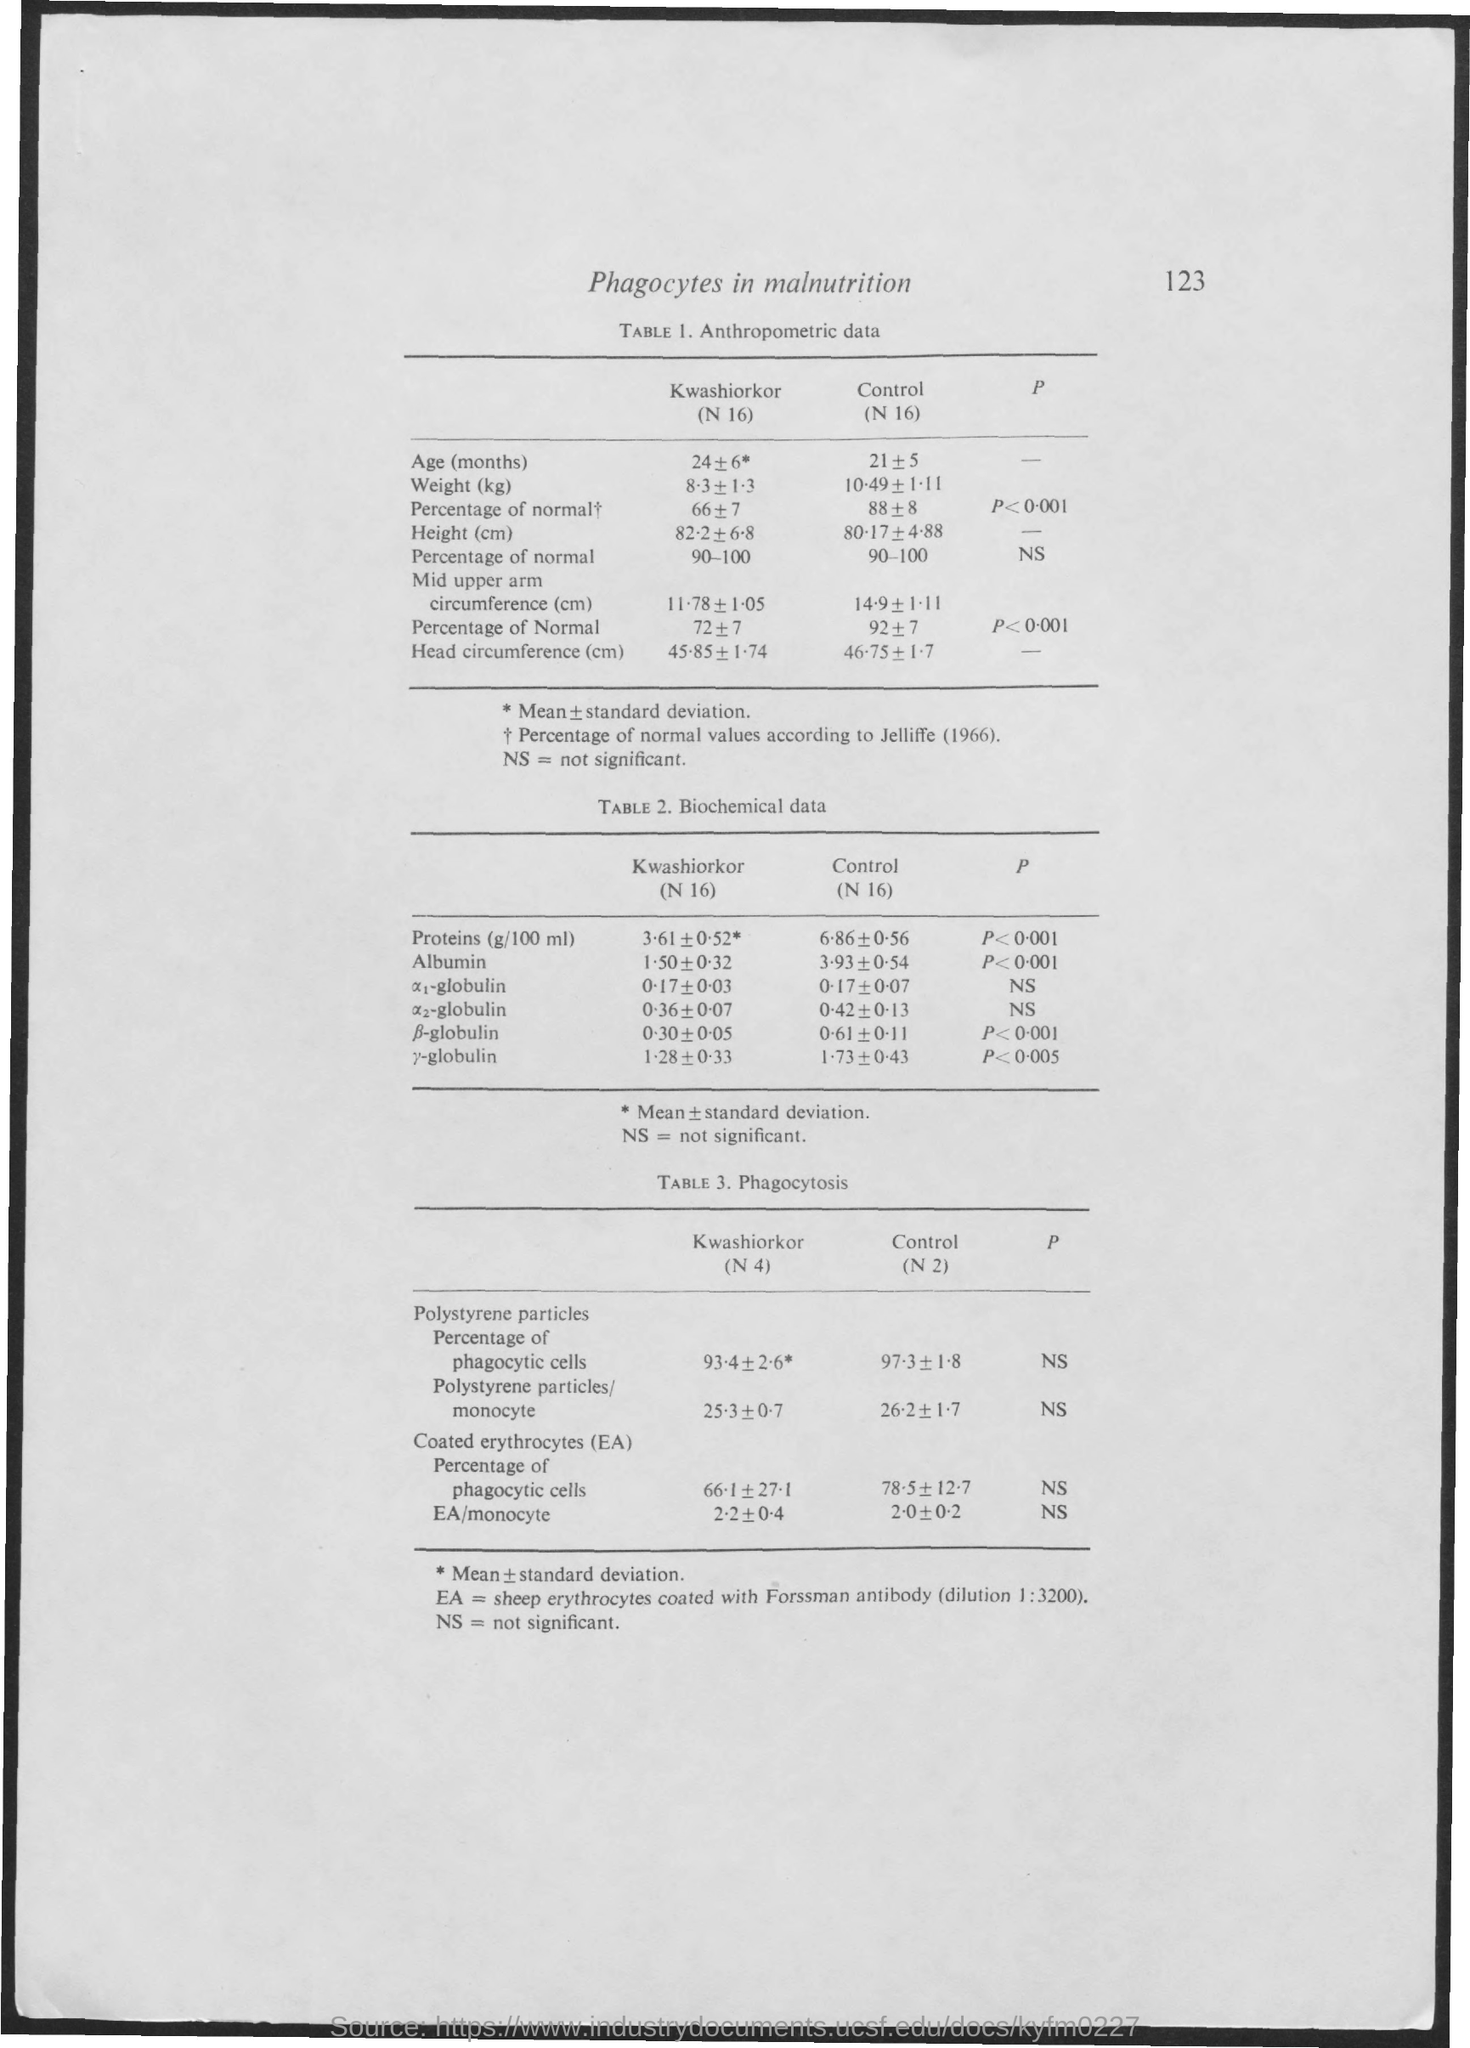What is the title given?
Provide a short and direct response. Phagocytes in malnutrition. What is the title of table 1?
Provide a succinct answer. Anthropometric data. What does NS stand for?
Your answer should be very brief. Not significant. According to whom is the percentage of normal values?
Give a very brief answer. Jelliffe (1966). What is the title of Table 3?
Give a very brief answer. Phagocytosis. What does EA signify in table 3?
Give a very brief answer. Sheep erythrocytes coated with forssman antibody (dilution 1:3200). 